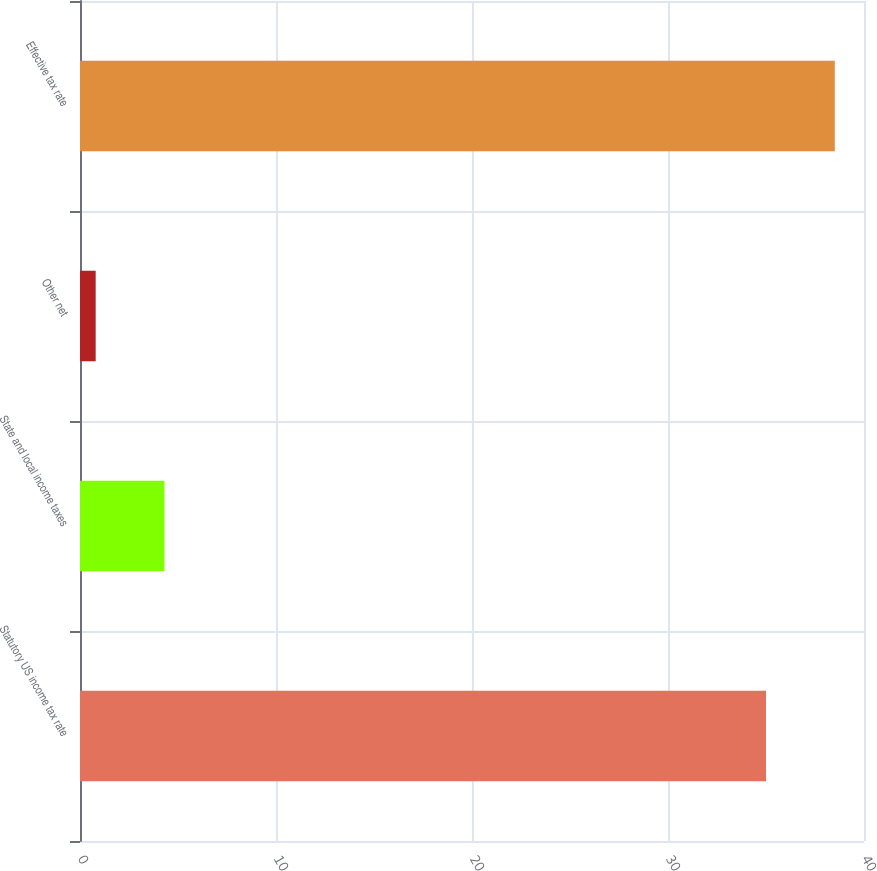Convert chart to OTSL. <chart><loc_0><loc_0><loc_500><loc_500><bar_chart><fcel>Statutory US income tax rate<fcel>State and local income taxes<fcel>Other net<fcel>Effective tax rate<nl><fcel>35<fcel>4.31<fcel>0.8<fcel>38.51<nl></chart> 